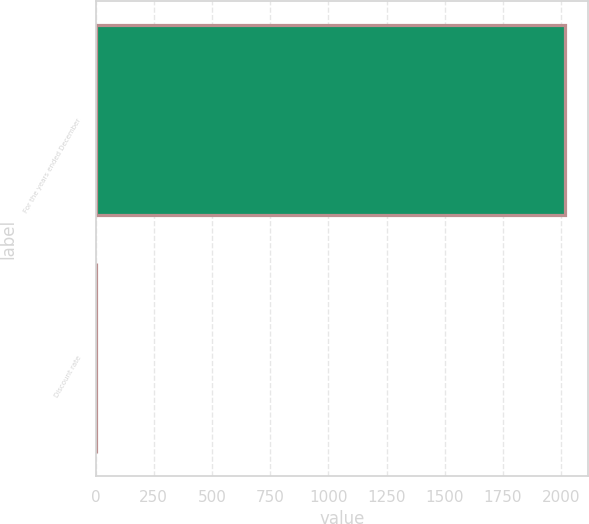Convert chart to OTSL. <chart><loc_0><loc_0><loc_500><loc_500><bar_chart><fcel>For the years ended December<fcel>Discount rate<nl><fcel>2016<fcel>4<nl></chart> 